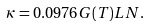<formula> <loc_0><loc_0><loc_500><loc_500>\kappa = 0 . 0 9 7 6 G ( T ) L N .</formula> 